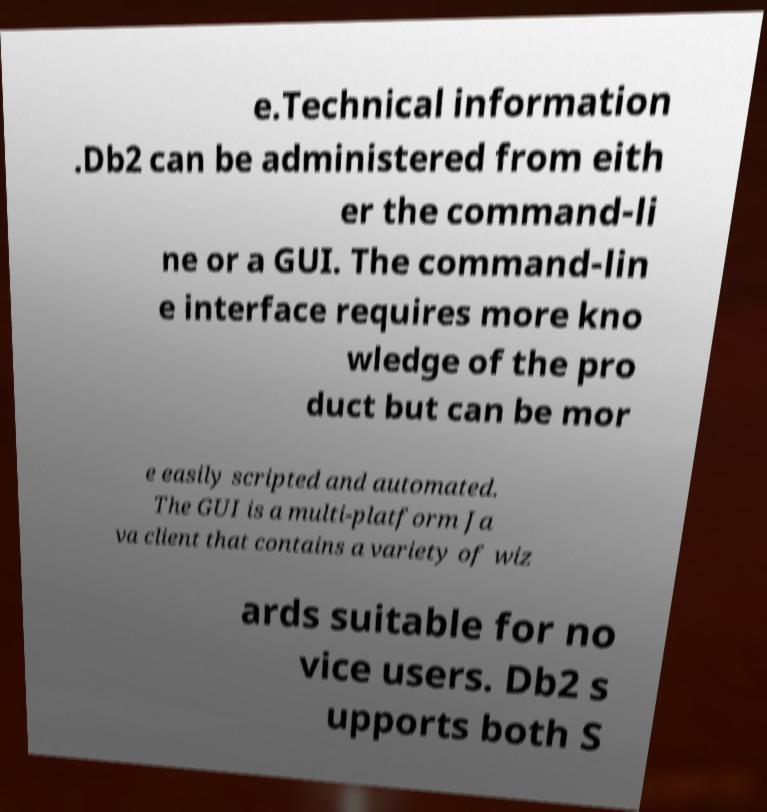Can you read and provide the text displayed in the image?This photo seems to have some interesting text. Can you extract and type it out for me? e.Technical information .Db2 can be administered from eith er the command-li ne or a GUI. The command-lin e interface requires more kno wledge of the pro duct but can be mor e easily scripted and automated. The GUI is a multi-platform Ja va client that contains a variety of wiz ards suitable for no vice users. Db2 s upports both S 